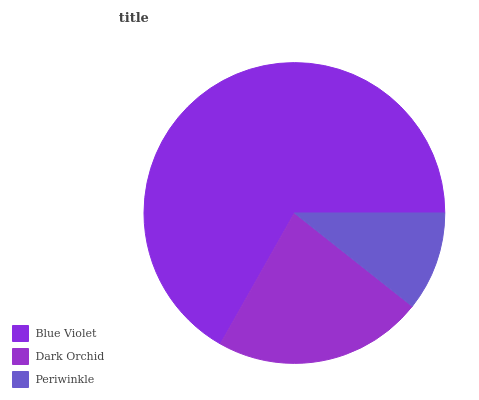Is Periwinkle the minimum?
Answer yes or no. Yes. Is Blue Violet the maximum?
Answer yes or no. Yes. Is Dark Orchid the minimum?
Answer yes or no. No. Is Dark Orchid the maximum?
Answer yes or no. No. Is Blue Violet greater than Dark Orchid?
Answer yes or no. Yes. Is Dark Orchid less than Blue Violet?
Answer yes or no. Yes. Is Dark Orchid greater than Blue Violet?
Answer yes or no. No. Is Blue Violet less than Dark Orchid?
Answer yes or no. No. Is Dark Orchid the high median?
Answer yes or no. Yes. Is Dark Orchid the low median?
Answer yes or no. Yes. Is Blue Violet the high median?
Answer yes or no. No. Is Periwinkle the low median?
Answer yes or no. No. 